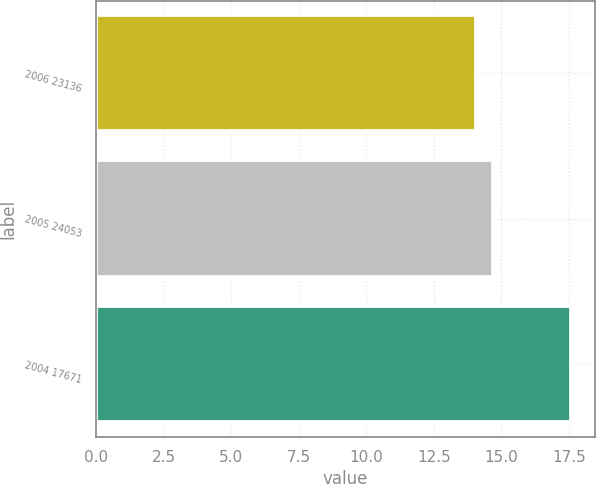Convert chart to OTSL. <chart><loc_0><loc_0><loc_500><loc_500><bar_chart><fcel>2006 23136<fcel>2005 24053<fcel>2004 17671<nl><fcel>14.05<fcel>14.68<fcel>17.59<nl></chart> 